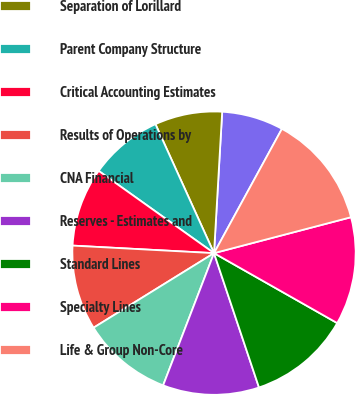Convert chart. <chart><loc_0><loc_0><loc_500><loc_500><pie_chart><fcel>Consolidated Financial Results<fcel>Separation of Lorillard<fcel>Parent Company Structure<fcel>Critical Accounting Estimates<fcel>Results of Operations by<fcel>CNA Financial<fcel>Reserves - Estimates and<fcel>Standard Lines<fcel>Specialty Lines<fcel>Life & Group Non-Core<nl><fcel>7.04%<fcel>7.7%<fcel>8.36%<fcel>9.01%<fcel>9.67%<fcel>10.33%<fcel>10.99%<fcel>11.64%<fcel>12.3%<fcel>12.96%<nl></chart> 